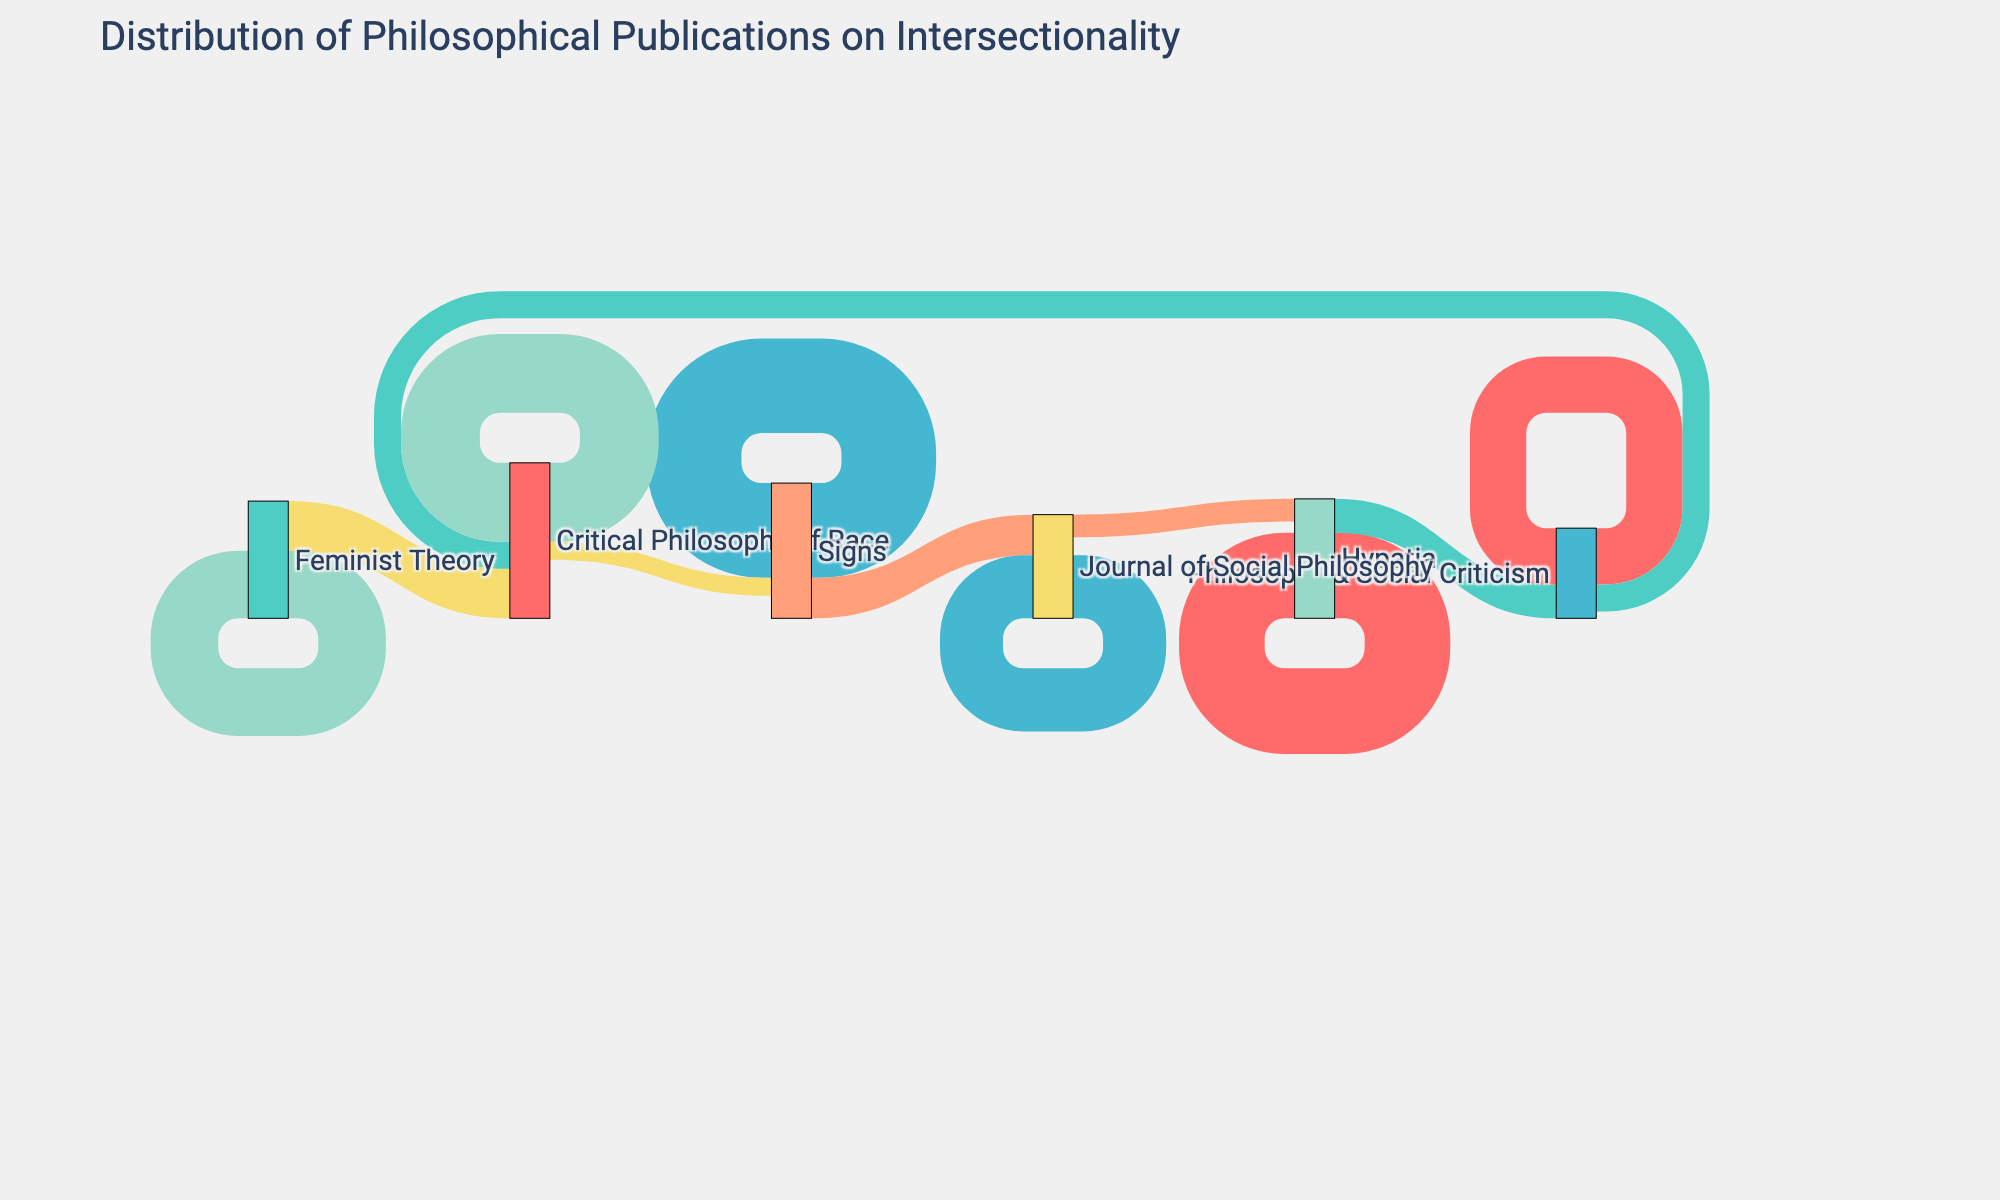What's the title of the figure? The title of a figure is usually displayed at the top, often in a larger or bold font. In this case, it is "Distribution of Philosophical Publications on Intersectionality" as mentioned in the Sankey Diagram layout.
Answer: Distribution of Philosophical Publications on Intersectionality Which journal has the highest number of publications about intersectionality? Look for the largest node, which represents the number of publications. In this diagram, "Signs" has the largest single node with 42 publications.
Answer: Signs What is the total number of publications by Hypatia and Signs combined? For Hypatia, sum 38 (to Hypatia) and 15 (to Philosophy & Social Criticism), which is 53. For Signs, sum 42 (to Signs) and 18 (to Journal of Social Philosophy), which is 60. Adding these totals, we get 53 + 60.
Answer: 113 Compare the number of publications in "Critical Philosophy of Race" from "Feminist Theory" and "Philosophy & Social Criticism". Which is more and by how much? Feminist Theory contributes 22 publications, and Philosophy & Social Criticism contributes 12 to Critical Philosophy of Race. The difference is 22 - 12.
Answer: Feminist Theory by 10 What is the most frequent target journal for "Journal of Social Philosophy"? The "Journal of Social Philosophy" has 28 publications to itself and 10 to "Hypatia". The highest value here is 28.
Answer: Journal of Social Philosophy What's the total number of publications recorded in the Sankey Diagram? Sum all the publication values: 38, 15, 42, 18, 30, 22, 25, 12, 28, 10, 35, 8. Adding these gives: 38 + 15 + 42 + 18 + 30 + 22 + 25 + 12 + 28 + 10 + 35 + 8 = 283.
Answer: 283 Which source journals contribute publications to "Critical Philosophy of Race"? Trace all the links leading to "Critical Philosophy of Race": from "Feminist Theory" with 22 and "Philosophy & Social Criticism" with 12.
Answer: Feminist Theory and Philosophy & Social Criticism Compute the average number of publications "Critical Philosophy of Race" receives from its source journals. "Critical Philosophy of Race" receives 22 publications from Feminist Theory and 12 from Philosophy & Social Criticism. Average is calculated by (22 + 12) / 2 = 34 / 2.
Answer: 17 